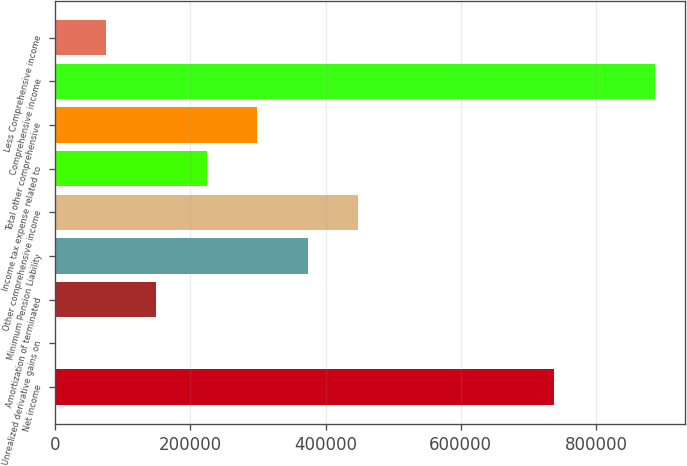Convert chart. <chart><loc_0><loc_0><loc_500><loc_500><bar_chart><fcel>Net income<fcel>Unrealized derivative gains on<fcel>Amortization of terminated<fcel>Minimum Pension Liability<fcel>Other comprehensive income<fcel>Income tax expense related to<fcel>Total other comprehensive<fcel>Comprehensive income<fcel>Less Comprehensive income<nl><fcel>738024<fcel>0.17<fcel>149402<fcel>373506<fcel>448207<fcel>224103<fcel>298804<fcel>887426<fcel>74701.2<nl></chart> 